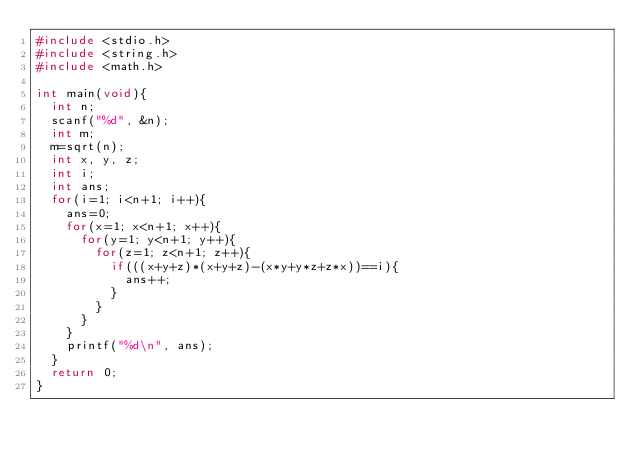<code> <loc_0><loc_0><loc_500><loc_500><_C_>#include <stdio.h>
#include <string.h>
#include <math.h>

int main(void){
  int n;
  scanf("%d", &n);
  int m;
  m=sqrt(n);
  int x, y, z;
  int i;
  int ans;
  for(i=1; i<n+1; i++){
    ans=0;
    for(x=1; x<n+1; x++){
      for(y=1; y<n+1; y++){
        for(z=1; z<n+1; z++){
          if(((x+y+z)*(x+y+z)-(x*y+y*z+z*x))==i){
            ans++;
          }
        }
      }
    }
    printf("%d\n", ans);
  }
  return 0;
}
</code> 